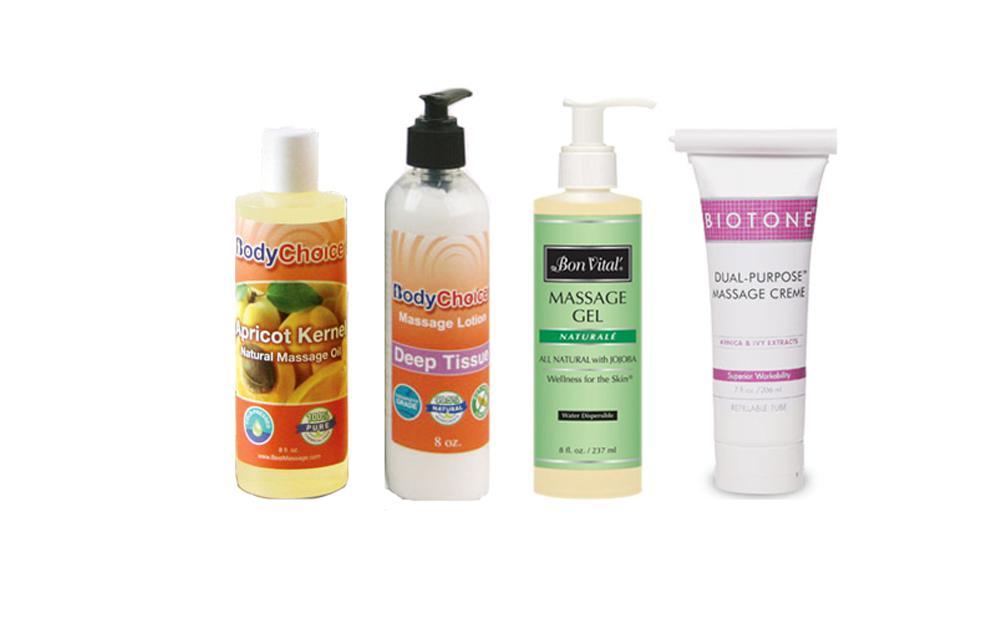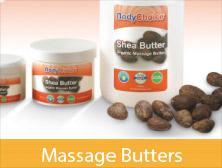The first image is the image on the left, the second image is the image on the right. Given the left and right images, does the statement "There is a human body visible in one image." hold true? Answer yes or no. No. The first image is the image on the left, the second image is the image on the right. Given the left and right images, does the statement "Part of the human body is visible in one of the images." hold true? Answer yes or no. No. 